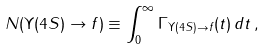Convert formula to latex. <formula><loc_0><loc_0><loc_500><loc_500>N ( \Upsilon ( 4 S ) \to f ) \equiv \int _ { 0 } ^ { \infty } \Gamma _ { \Upsilon ( 4 S ) \to f } ( t ) \, d t \, ,</formula> 